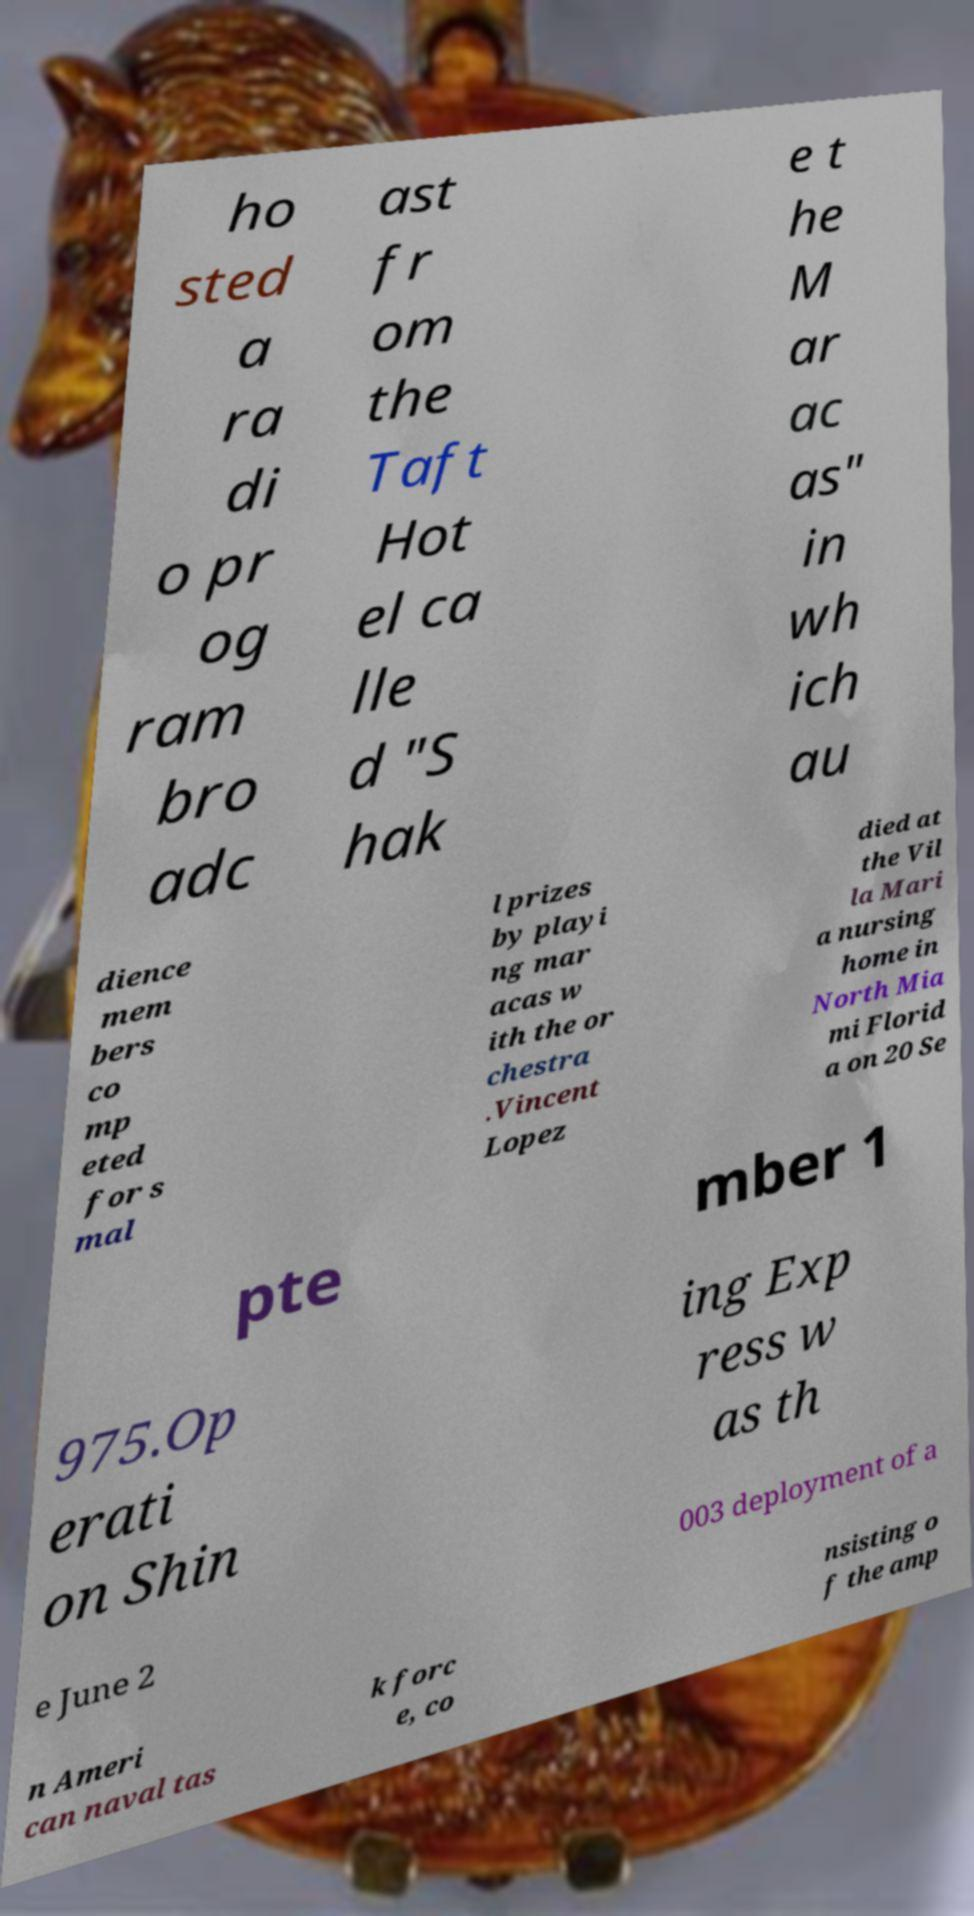There's text embedded in this image that I need extracted. Can you transcribe it verbatim? ho sted a ra di o pr og ram bro adc ast fr om the Taft Hot el ca lle d "S hak e t he M ar ac as" in wh ich au dience mem bers co mp eted for s mal l prizes by playi ng mar acas w ith the or chestra .Vincent Lopez died at the Vil la Mari a nursing home in North Mia mi Florid a on 20 Se pte mber 1 975.Op erati on Shin ing Exp ress w as th e June 2 003 deployment of a n Ameri can naval tas k forc e, co nsisting o f the amp 